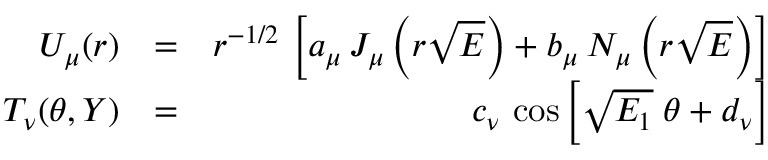<formula> <loc_0><loc_0><loc_500><loc_500>\begin{array} { r l r } { U _ { \mu } ( r ) } & { = } & { r ^ { - 1 / 2 } \, \left [ a _ { \mu } \, J _ { \mu } \left ( { r \sqrt { E } } \right ) + b _ { \mu } \, N _ { \mu } \left ( r \sqrt { E } \right ) \right ] } \\ { T _ { \nu } ( \theta , Y ) } & { = } & { c _ { \nu } \, \cos \left [ \sqrt { E _ { 1 } } \, \theta + d _ { \nu } \right ] } \end{array}</formula> 